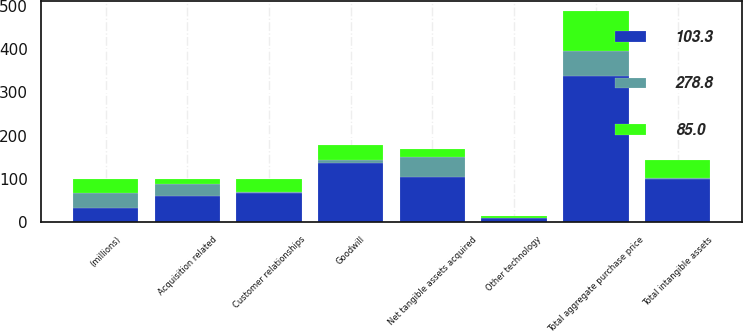Convert chart. <chart><loc_0><loc_0><loc_500><loc_500><stacked_bar_chart><ecel><fcel>(millions)<fcel>Net tangible assets acquired<fcel>Customer relationships<fcel>Other technology<fcel>Total intangible assets<fcel>Goodwill<fcel>Total aggregate purchase price<fcel>Acquisition related<nl><fcel>278.8<fcel>32.9<fcel>46.9<fcel>2.6<fcel>1.1<fcel>3.7<fcel>7.3<fcel>57.9<fcel>27.1<nl><fcel>103.3<fcel>32.9<fcel>103.7<fcel>65.6<fcel>8.7<fcel>98.7<fcel>136.9<fcel>339.3<fcel>60.5<nl><fcel>85<fcel>32.9<fcel>18.2<fcel>32<fcel>4.5<fcel>39.9<fcel>32.9<fcel>91<fcel>12.3<nl></chart> 